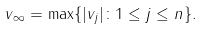<formula> <loc_0><loc_0><loc_500><loc_500>\| v \| _ { \infty } = \max \{ | v _ { j } | \colon 1 \leq j \leq n \} .</formula> 